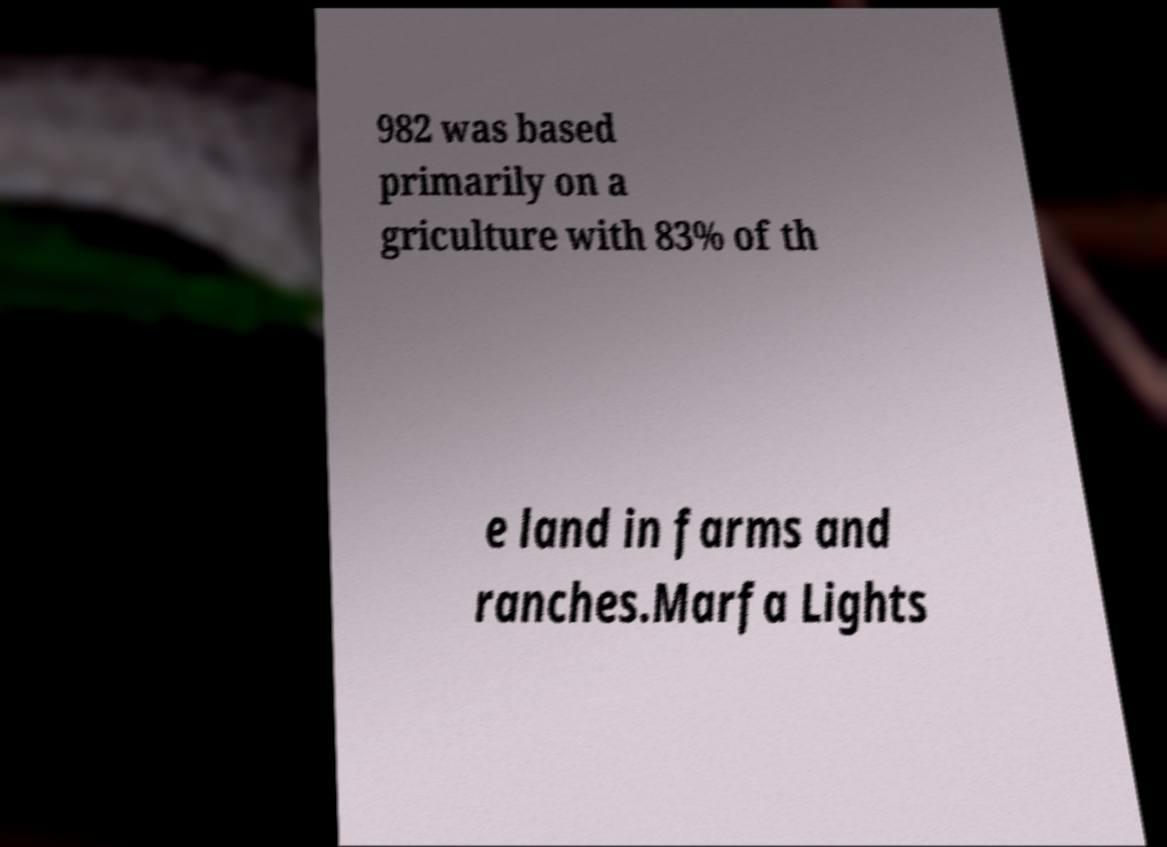Could you extract and type out the text from this image? 982 was based primarily on a griculture with 83% of th e land in farms and ranches.Marfa Lights 